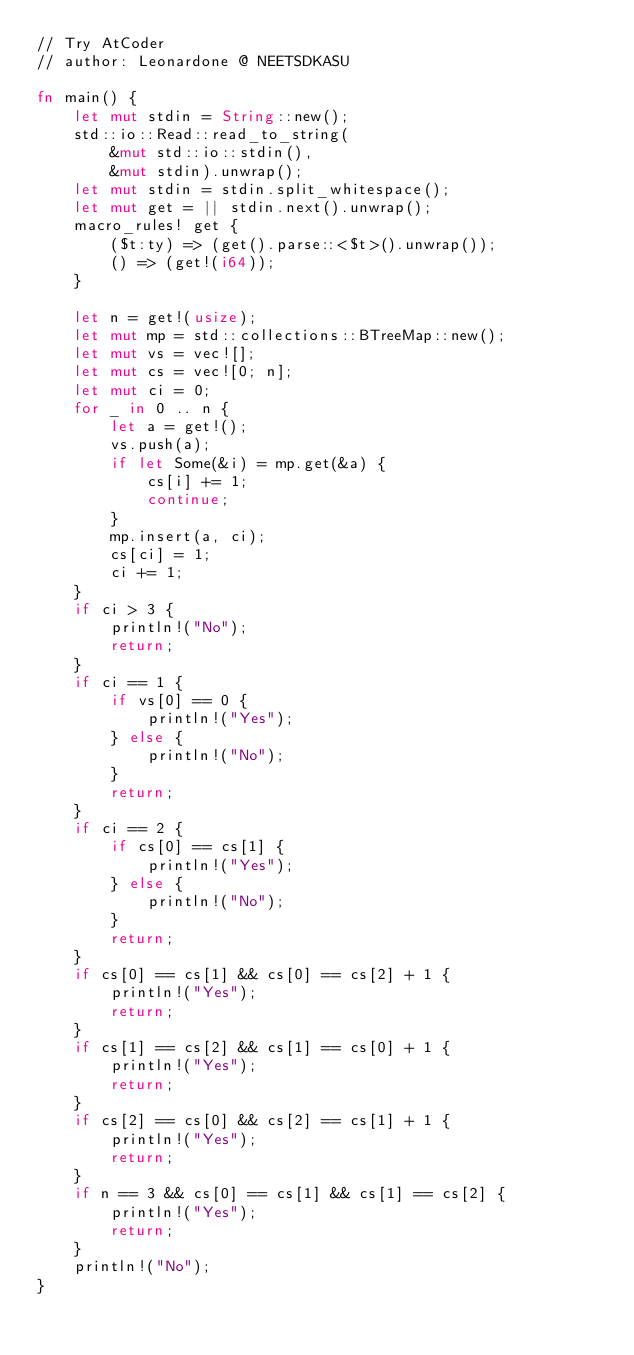<code> <loc_0><loc_0><loc_500><loc_500><_Rust_>// Try AtCoder
// author: Leonardone @ NEETSDKASU

fn main() {
    let mut stdin = String::new();
    std::io::Read::read_to_string(
        &mut std::io::stdin(),
        &mut stdin).unwrap();
    let mut stdin = stdin.split_whitespace();
    let mut get = || stdin.next().unwrap();
    macro_rules! get {
        ($t:ty) => (get().parse::<$t>().unwrap());
        () => (get!(i64));
    }
    
    let n = get!(usize);
    let mut mp = std::collections::BTreeMap::new();
    let mut vs = vec![];
    let mut cs = vec![0; n];
    let mut ci = 0;
    for _ in 0 .. n {
    	let a = get!();
        vs.push(a);
        if let Some(&i) = mp.get(&a) {
            cs[i] += 1;
            continue;
        }
        mp.insert(a, ci);
        cs[ci] = 1;
        ci += 1;
    }
    if ci > 3 {
        println!("No");
        return;
    }
    if ci == 1 {
        if vs[0] == 0 {
            println!("Yes");
        } else {
            println!("No");
        }
        return;
    }
    if ci == 2 {
        if cs[0] == cs[1] {
            println!("Yes");
        } else {
            println!("No");
        }
        return;
    }
    if cs[0] == cs[1] && cs[0] == cs[2] + 1 {
        println!("Yes");
        return;
    }
    if cs[1] == cs[2] && cs[1] == cs[0] + 1 {
        println!("Yes");
        return;
    }
    if cs[2] == cs[0] && cs[2] == cs[1] + 1 {
        println!("Yes");
        return;
    }
    if n == 3 && cs[0] == cs[1] && cs[1] == cs[2] {
        println!("Yes");
        return;
    }
    println!("No");
}</code> 